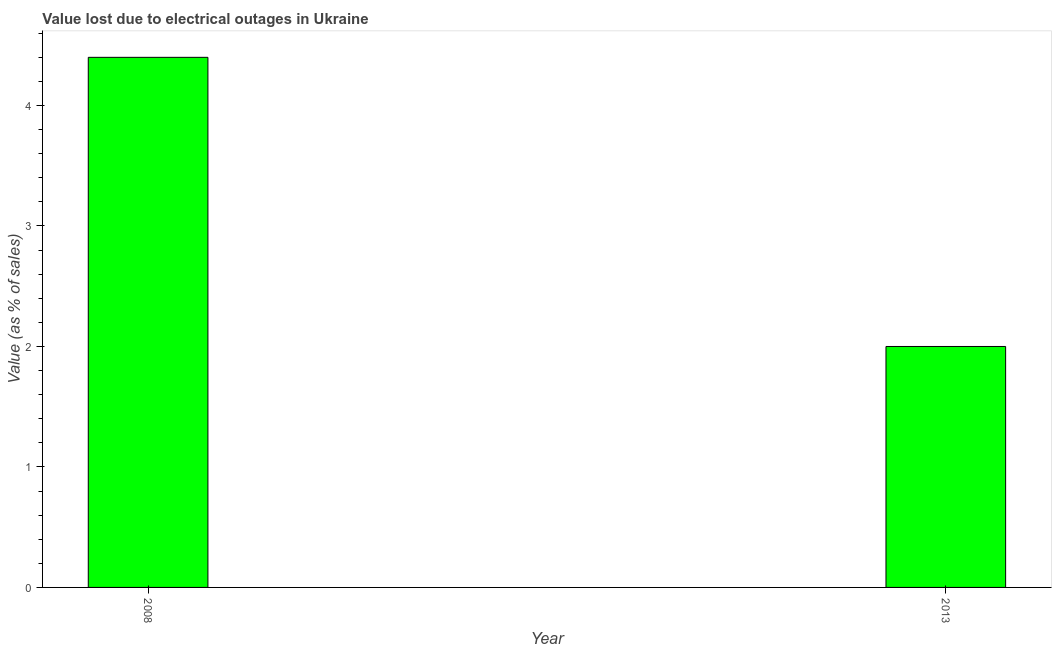Does the graph contain any zero values?
Provide a short and direct response. No. What is the title of the graph?
Provide a succinct answer. Value lost due to electrical outages in Ukraine. What is the label or title of the Y-axis?
Provide a succinct answer. Value (as % of sales). In which year was the value lost due to electrical outages maximum?
Ensure brevity in your answer.  2008. What is the sum of the value lost due to electrical outages?
Provide a short and direct response. 6.4. What is the difference between the value lost due to electrical outages in 2008 and 2013?
Offer a terse response. 2.4. What is the average value lost due to electrical outages per year?
Ensure brevity in your answer.  3.2. What is the median value lost due to electrical outages?
Offer a terse response. 3.2. In how many years, is the value lost due to electrical outages greater than 2.2 %?
Your answer should be very brief. 1. Do a majority of the years between 2008 and 2013 (inclusive) have value lost due to electrical outages greater than 3.4 %?
Give a very brief answer. No. What is the ratio of the value lost due to electrical outages in 2008 to that in 2013?
Offer a very short reply. 2.2. Is the value lost due to electrical outages in 2008 less than that in 2013?
Ensure brevity in your answer.  No. In how many years, is the value lost due to electrical outages greater than the average value lost due to electrical outages taken over all years?
Provide a succinct answer. 1. Are all the bars in the graph horizontal?
Your answer should be very brief. No. What is the Value (as % of sales) in 2008?
Make the answer very short. 4.4. What is the Value (as % of sales) in 2013?
Your answer should be very brief. 2. What is the difference between the Value (as % of sales) in 2008 and 2013?
Make the answer very short. 2.4. 